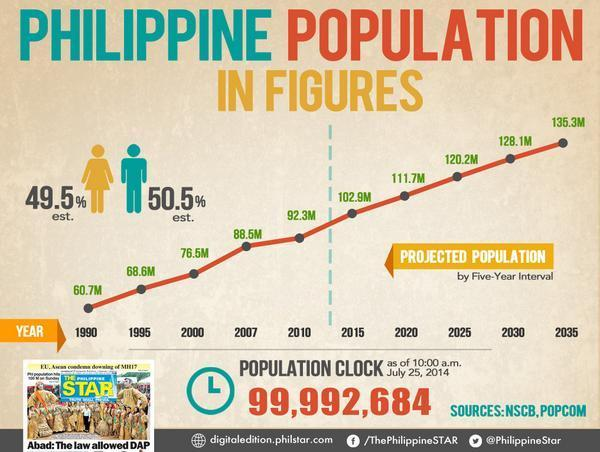What is the estimated population percentage of women in Philippines in 2014?
Answer the question with a short phrase. 49.5% What was the population of Philippines in 2000? 76.5M What is the estimated population percentage of men in Philippines in 2014? 50.5% What is the projected population of Philippines in 2030? 128.1M 